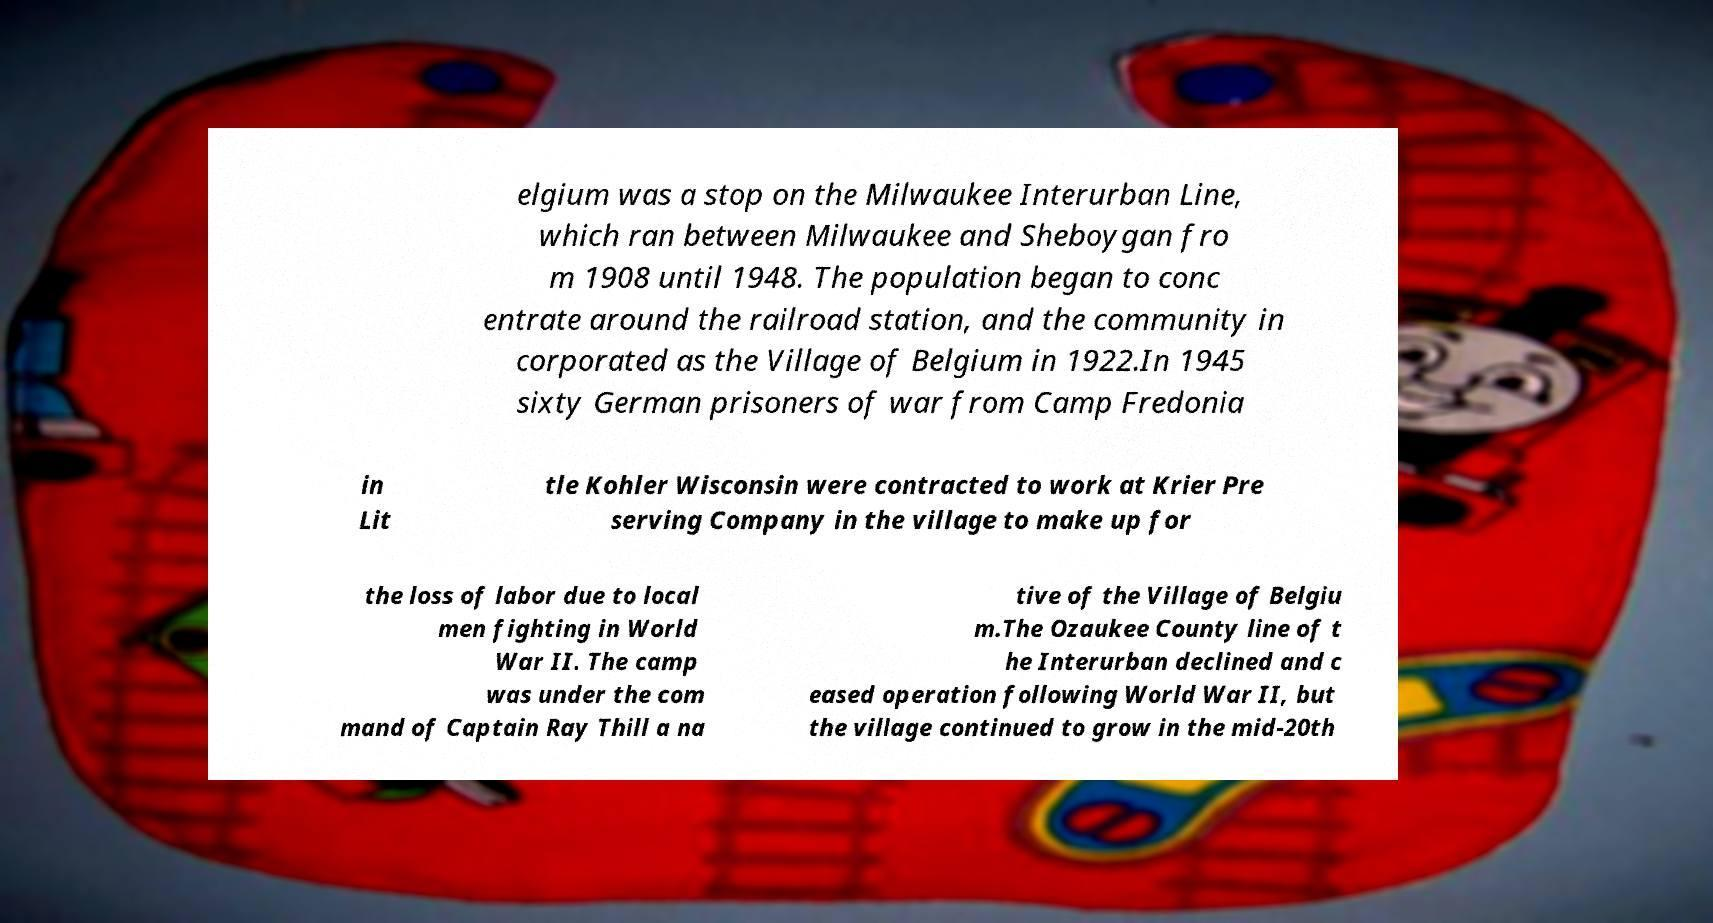Can you accurately transcribe the text from the provided image for me? elgium was a stop on the Milwaukee Interurban Line, which ran between Milwaukee and Sheboygan fro m 1908 until 1948. The population began to conc entrate around the railroad station, and the community in corporated as the Village of Belgium in 1922.In 1945 sixty German prisoners of war from Camp Fredonia in Lit tle Kohler Wisconsin were contracted to work at Krier Pre serving Company in the village to make up for the loss of labor due to local men fighting in World War II. The camp was under the com mand of Captain Ray Thill a na tive of the Village of Belgiu m.The Ozaukee County line of t he Interurban declined and c eased operation following World War II, but the village continued to grow in the mid-20th 